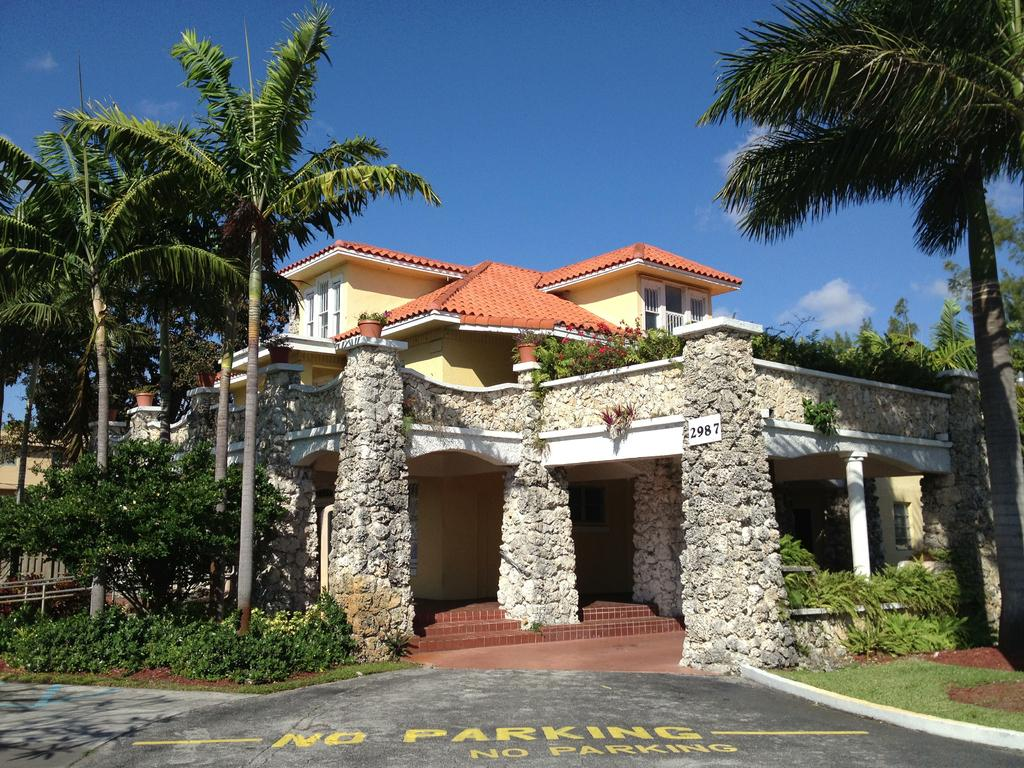What types of vegetation can be seen in the foreground of the image? There are trees and plants in the foreground area of the image. What type of structure is visible in the foreground of the image? There is a house in the foreground area of the image. What can be seen in the background of the image? The sky is visible in the background of the image. What type of thread is being used to hold the leg of the bean in the image? There is no thread, leg, or bean present in the image. 